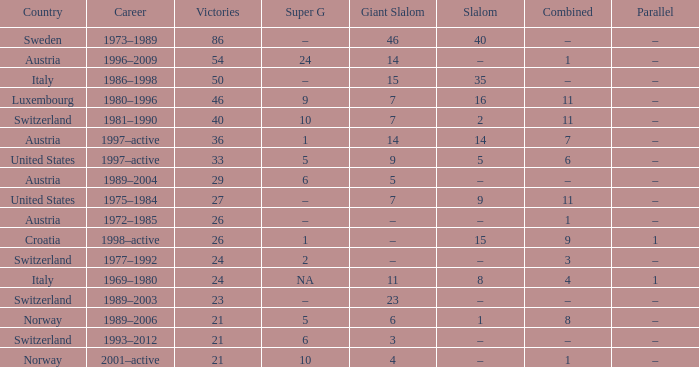Which giant slalom competitor has more than 27 victories, no slalom achievements, and a career spanning from 1996 to 2009? 14.0. 